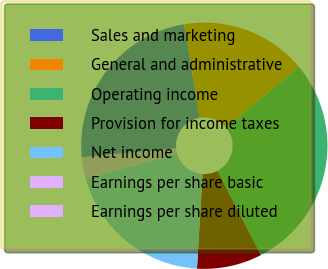Convert chart. <chart><loc_0><loc_0><loc_500><loc_500><pie_chart><fcel>Sales and marketing<fcel>General and administrative<fcel>Operating income<fcel>Provision for income taxes<fcel>Net income<fcel>Earnings per share basic<fcel>Earnings per share diluted<nl><fcel>23.88%<fcel>16.55%<fcel>28.46%<fcel>8.56%<fcel>19.7%<fcel>2.85%<fcel>0.0%<nl></chart> 